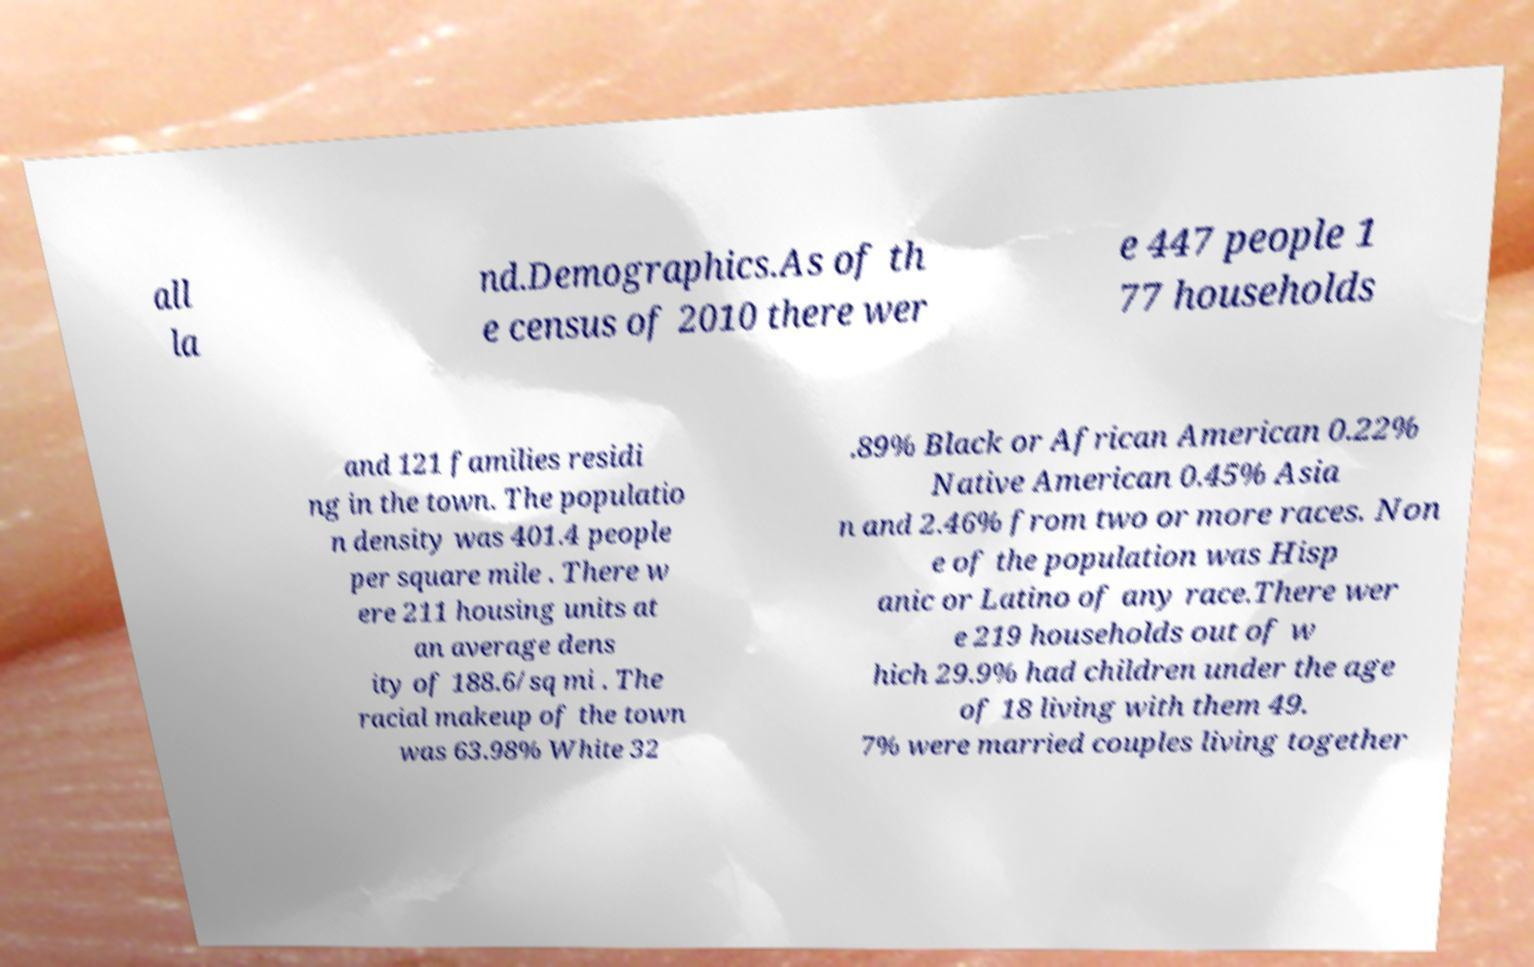I need the written content from this picture converted into text. Can you do that? all la nd.Demographics.As of th e census of 2010 there wer e 447 people 1 77 households and 121 families residi ng in the town. The populatio n density was 401.4 people per square mile . There w ere 211 housing units at an average dens ity of 188.6/sq mi . The racial makeup of the town was 63.98% White 32 .89% Black or African American 0.22% Native American 0.45% Asia n and 2.46% from two or more races. Non e of the population was Hisp anic or Latino of any race.There wer e 219 households out of w hich 29.9% had children under the age of 18 living with them 49. 7% were married couples living together 